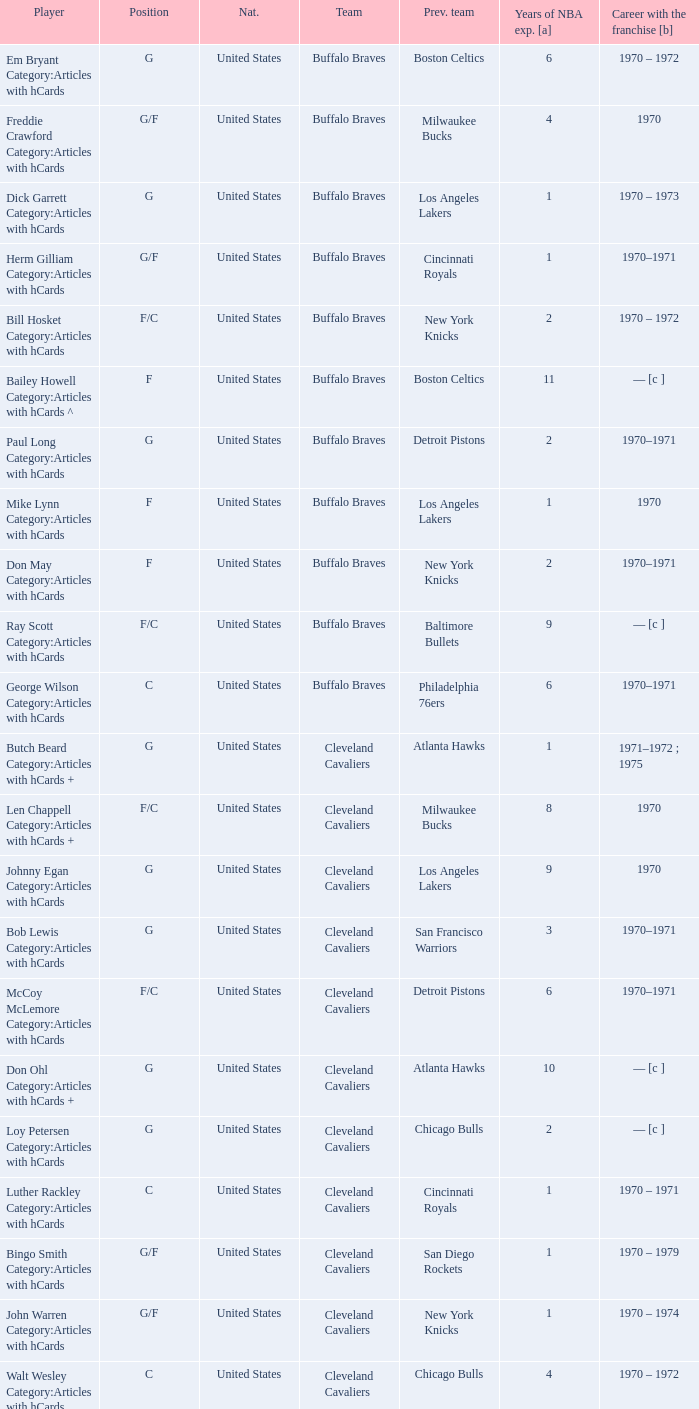Who is the player with 7 years of NBA experience? Larry Siegfried Category:Articles with hCards. Help me parse the entirety of this table. {'header': ['Player', 'Position', 'Nat.', 'Team', 'Prev. team', 'Years of NBA exp. [a]', 'Career with the franchise [b]'], 'rows': [['Em Bryant Category:Articles with hCards', 'G', 'United States', 'Buffalo Braves', 'Boston Celtics', '6', '1970 – 1972'], ['Freddie Crawford Category:Articles with hCards', 'G/F', 'United States', 'Buffalo Braves', 'Milwaukee Bucks', '4', '1970'], ['Dick Garrett Category:Articles with hCards', 'G', 'United States', 'Buffalo Braves', 'Los Angeles Lakers', '1', '1970 – 1973'], ['Herm Gilliam Category:Articles with hCards', 'G/F', 'United States', 'Buffalo Braves', 'Cincinnati Royals', '1', '1970–1971'], ['Bill Hosket Category:Articles with hCards', 'F/C', 'United States', 'Buffalo Braves', 'New York Knicks', '2', '1970 – 1972'], ['Bailey Howell Category:Articles with hCards ^', 'F', 'United States', 'Buffalo Braves', 'Boston Celtics', '11', '— [c ]'], ['Paul Long Category:Articles with hCards', 'G', 'United States', 'Buffalo Braves', 'Detroit Pistons', '2', '1970–1971'], ['Mike Lynn Category:Articles with hCards', 'F', 'United States', 'Buffalo Braves', 'Los Angeles Lakers', '1', '1970'], ['Don May Category:Articles with hCards', 'F', 'United States', 'Buffalo Braves', 'New York Knicks', '2', '1970–1971'], ['Ray Scott Category:Articles with hCards', 'F/C', 'United States', 'Buffalo Braves', 'Baltimore Bullets', '9', '— [c ]'], ['George Wilson Category:Articles with hCards', 'C', 'United States', 'Buffalo Braves', 'Philadelphia 76ers', '6', '1970–1971'], ['Butch Beard Category:Articles with hCards +', 'G', 'United States', 'Cleveland Cavaliers', 'Atlanta Hawks', '1', '1971–1972 ; 1975'], ['Len Chappell Category:Articles with hCards +', 'F/C', 'United States', 'Cleveland Cavaliers', 'Milwaukee Bucks', '8', '1970'], ['Johnny Egan Category:Articles with hCards', 'G', 'United States', 'Cleveland Cavaliers', 'Los Angeles Lakers', '9', '1970'], ['Bob Lewis Category:Articles with hCards', 'G', 'United States', 'Cleveland Cavaliers', 'San Francisco Warriors', '3', '1970–1971'], ['McCoy McLemore Category:Articles with hCards', 'F/C', 'United States', 'Cleveland Cavaliers', 'Detroit Pistons', '6', '1970–1971'], ['Don Ohl Category:Articles with hCards +', 'G', 'United States', 'Cleveland Cavaliers', 'Atlanta Hawks', '10', '— [c ]'], ['Loy Petersen Category:Articles with hCards', 'G', 'United States', 'Cleveland Cavaliers', 'Chicago Bulls', '2', '— [c ]'], ['Luther Rackley Category:Articles with hCards', 'C', 'United States', 'Cleveland Cavaliers', 'Cincinnati Royals', '1', '1970 – 1971'], ['Bingo Smith Category:Articles with hCards', 'G/F', 'United States', 'Cleveland Cavaliers', 'San Diego Rockets', '1', '1970 – 1979'], ['John Warren Category:Articles with hCards', 'G/F', 'United States', 'Cleveland Cavaliers', 'New York Knicks', '1', '1970 – 1974'], ['Walt Wesley Category:Articles with hCards', 'C', 'United States', 'Cleveland Cavaliers', 'Chicago Bulls', '4', '1970 – 1972'], ['Rick Adelman Category:Articles with hCards', 'G', 'United States', 'Portland Trail Blazers', 'San Diego Rockets', '2', '1970 – 1973'], ['Jerry Chambers Category:Articles with hCards', 'F', 'United States', 'Portland Trail Blazers', 'Phoenix Suns', '2', '— [c ]'], ['LeRoy Ellis Category:Articles with hCards', 'F/C', 'United States', 'Portland Trail Blazers', 'Baltimore Bullets', '8', '1970–1971'], ['Fred Hetzel Category:Articles with hCards', 'F/C', 'United States', 'Portland Trail Blazers', 'Philadelphia 76ers', '5', '— [c ]'], ['Joe Kennedy Category:Articles with hCards', 'F', 'United States', 'Portland Trail Blazers', 'Seattle SuperSonics', '2', '— [c ]'], ['Ed Manning Category:Articles with hCards', 'F', 'United States', 'Portland Trail Blazers', 'Chicago Bulls', '3', '1970–1971'], ['Stan McKenzie Category:Articles with hCards', 'G/F', 'United States', 'Portland Trail Blazers', 'Phoenix Suns', '3', '1970 – 1972'], ['Dorie Murrey Category:Articles with hCards', 'F/C', 'United States', 'Portland Trail Blazers', 'Seattle SuperSonics', '4', '1970'], ['Pat Riley Category:Articles with hCards', 'G/F', 'United States', 'Portland Trail Blazers', 'San Diego Rockets', '3', '— [c ]'], ['Dale Schlueter Category:Articles with hCards', 'C', 'United States', 'Portland Trail Blazers', 'San Francisco Warriors', '2', '1970 – 1972 ; 1977–1978'], ['Larry Siegfried Category:Articles with hCards', 'F', 'United States', 'Portland Trail Blazers', 'Boston Celtics', '7', '— [c ]']]} 